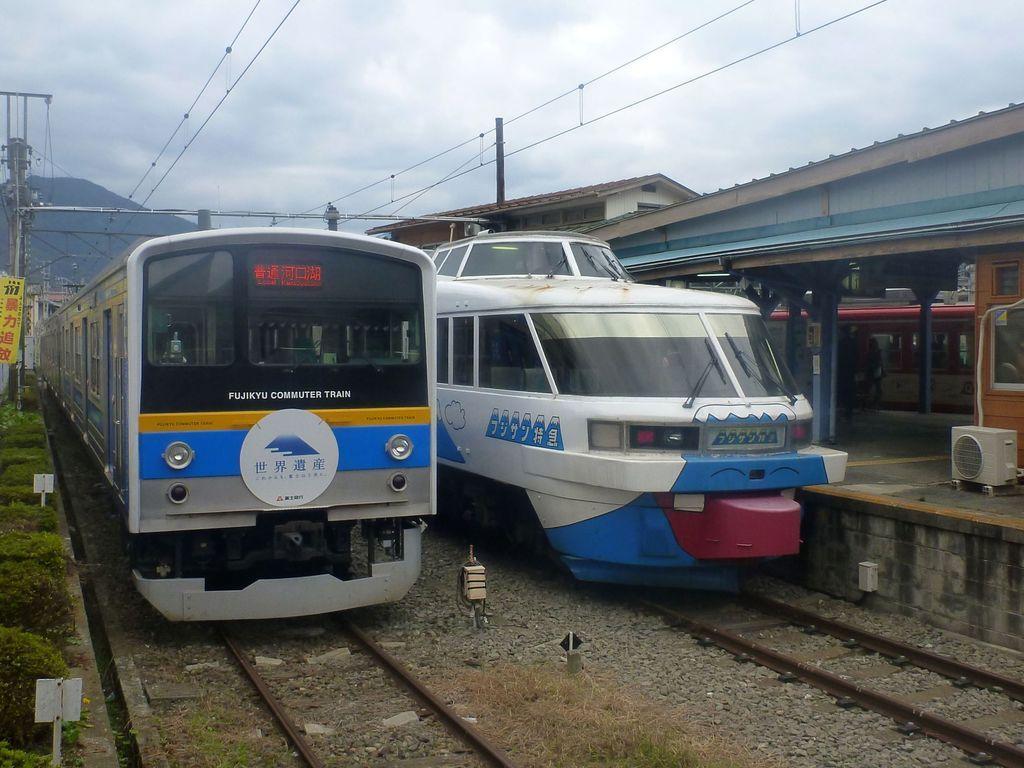Describe this image in one or two sentences. In this image I can see two trains on the track. On both sides I can see the poles. To the right I can see the platform, shed and the house. I can also see an another train. In the background I can see the mountains, clouds and the sky. 